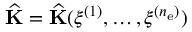<formula> <loc_0><loc_0><loc_500><loc_500>\widehat { K } = \widehat { K } ( \boldsymbol \xi ^ { ( 1 ) } , \dots , \boldsymbol \xi ^ { ( n _ { e } ) } )</formula> 